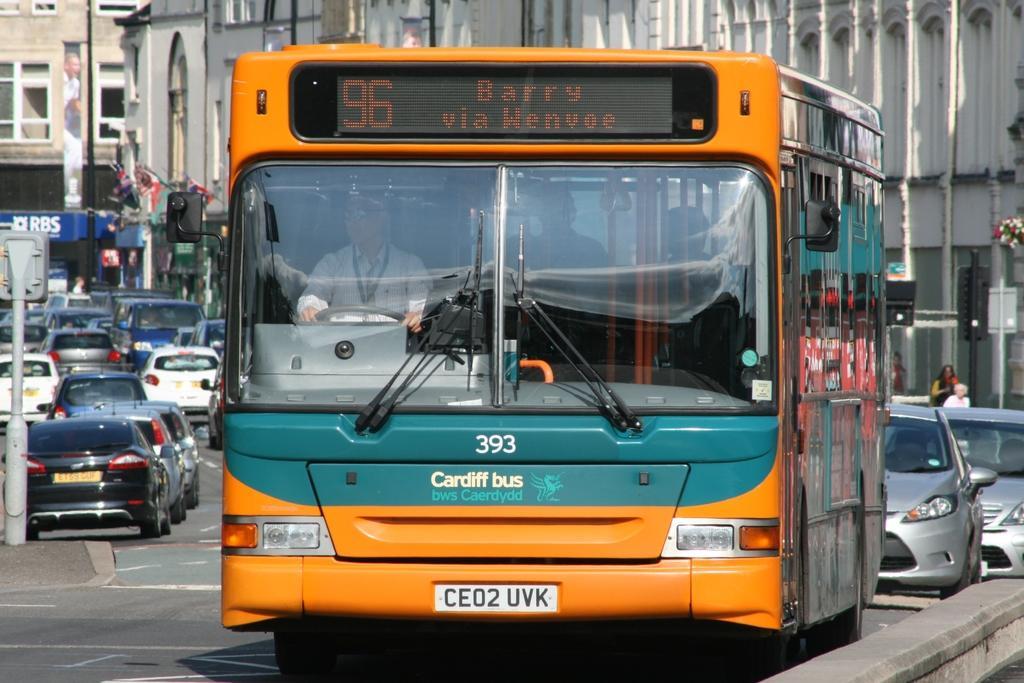In one or two sentences, can you explain what this image depicts? In the foreground I can see a bus and fleets of cars on the road. In the background I can see buildings, boards and windows. This image is taken on the road. 